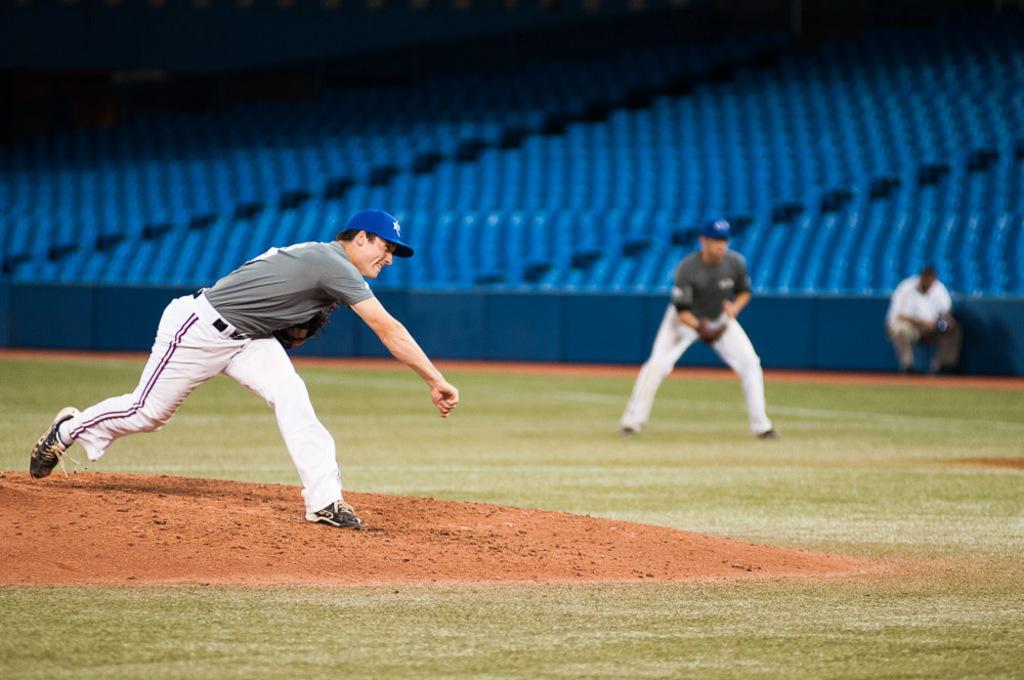Could you give a brief overview of what you see in this image? In this image there is one person standing at left side of this image and there is one person standing at middle of this image and one more is at right side of this image and there is a ground at bottom of this image and there are some chairs at top of this image. 